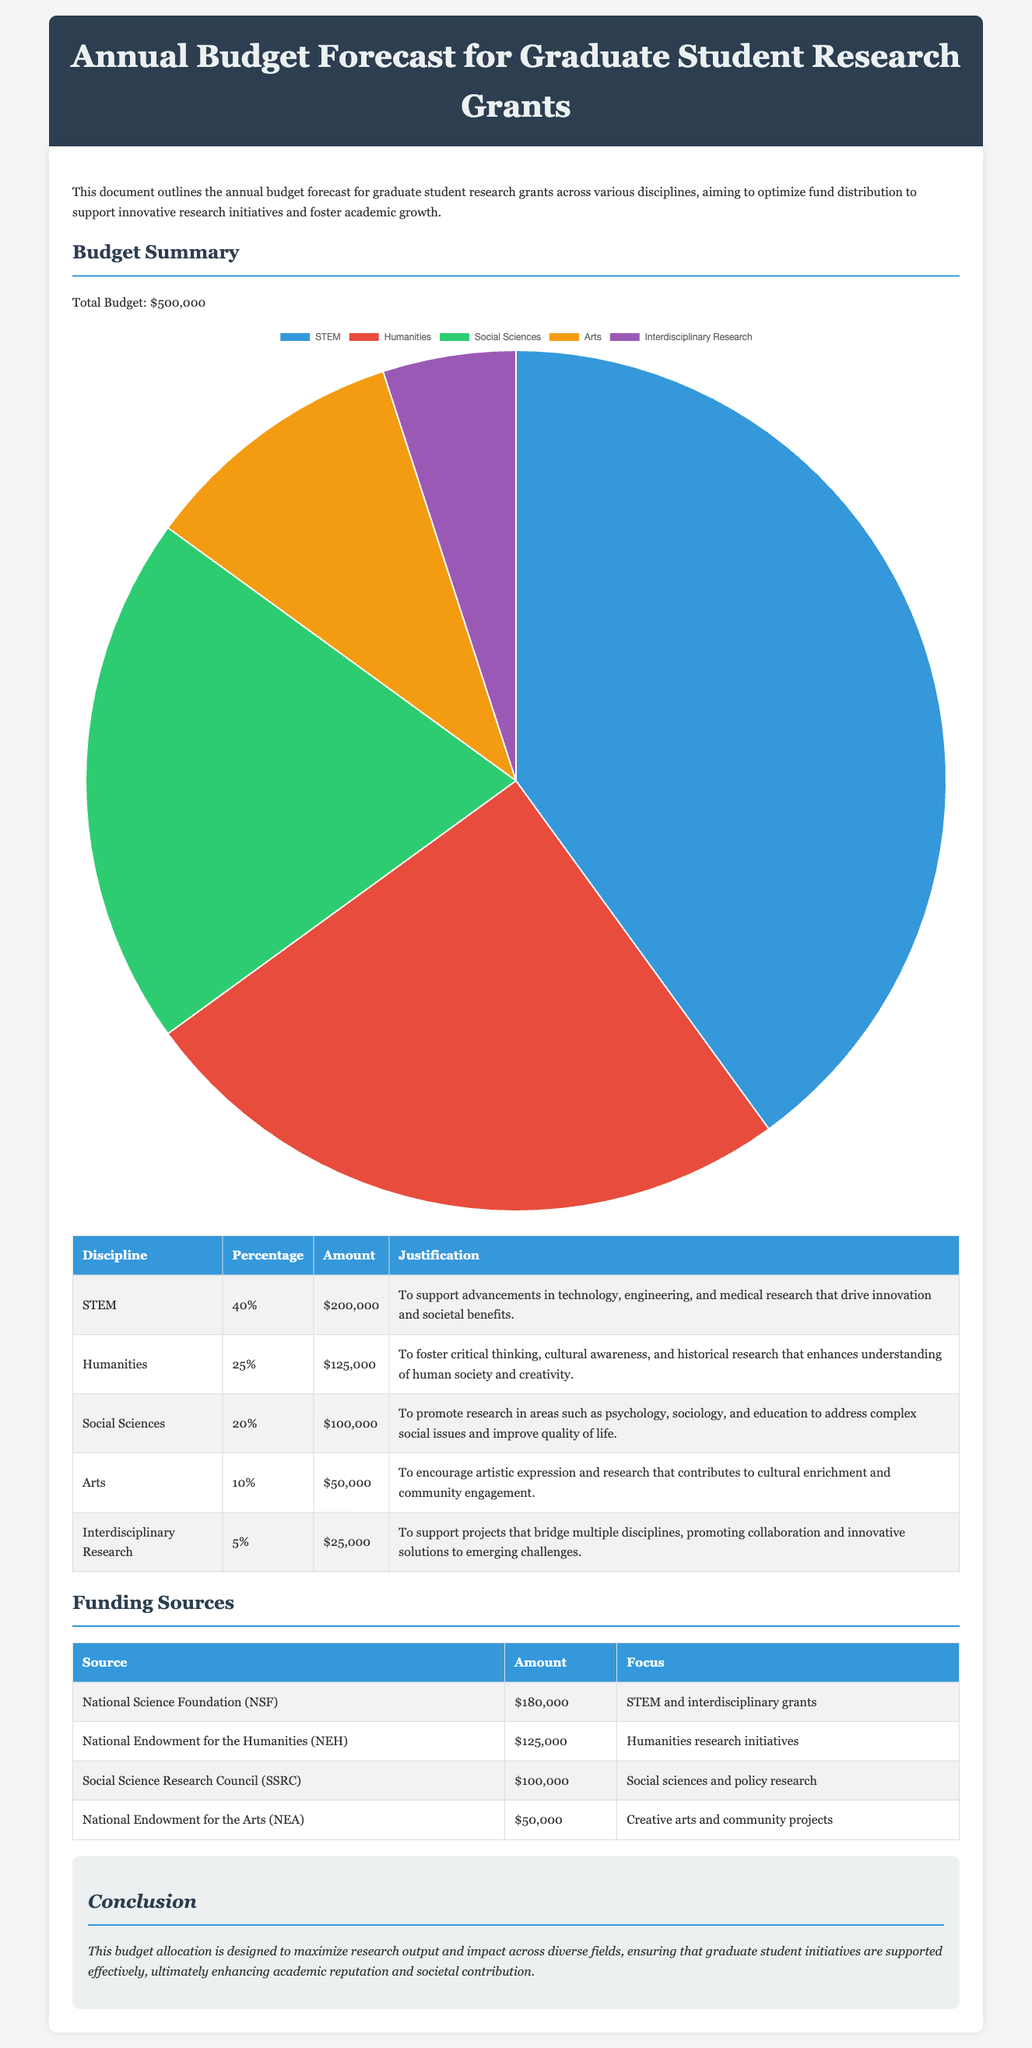What is the total budget? The total budget is explicitly mentioned in the document as the overall amount allocated for the grants.
Answer: $500,000 What percentage of the budget is allocated to STEM? The budget summary includes a breakdown of the percentages, indicating how much each discipline receives.
Answer: 40% How much funding is designated for the Humanities? The specific amount allocated for the Humanities is detailed in the funding distribution table.
Answer: $125,000 Which discipline receives the least amount of funding? The document specifies the funding for each discipline, allowing for straightforward identification of the smallest allocation.
Answer: Interdisciplinary Research Total funding from the National Endowment for the Arts? The total amount provided by this specific funding source is stated in the funding sources section.
Answer: $50,000 What is the primary focus of the funding from the National Science Foundation? The focus of the funding from this source is indicated in the description next to the allocated amount.
Answer: STEM and interdisciplinary grants How much of the budget is allocated to Social Sciences? The budget distribution lists the exact amount set aside for Social Sciences.
Answer: $100,000 What percentage of the total budget is allocated to Arts? The percentage allocated to Arts is included in the overall budget summary for disciplines.
Answer: 10% 